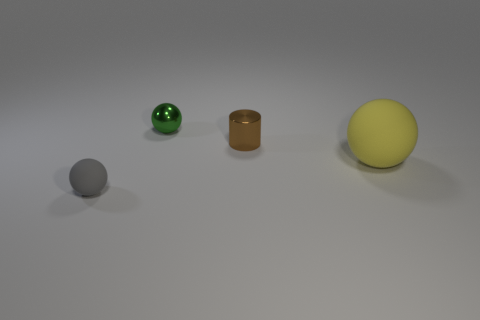Are there any other things that are the same size as the yellow sphere?
Make the answer very short. No. There is a large yellow thing that is the same shape as the tiny matte object; what is it made of?
Make the answer very short. Rubber. Do the brown thing and the green ball have the same material?
Your answer should be compact. Yes. There is a tiny ball that is behind the rubber sphere on the left side of the big sphere; what color is it?
Give a very brief answer. Green. The green thing that is the same material as the small brown thing is what size?
Provide a succinct answer. Small. How many large yellow things have the same shape as the small rubber thing?
Provide a succinct answer. 1. How many things are brown things that are on the left side of the yellow object or small metal things to the left of the small brown metallic cylinder?
Make the answer very short. 2. What number of yellow objects are on the left side of the ball on the right side of the shiny sphere?
Provide a succinct answer. 0. Does the tiny thing in front of the tiny brown cylinder have the same shape as the rubber object behind the gray rubber sphere?
Your answer should be very brief. Yes. Is there another thing made of the same material as the tiny green thing?
Your answer should be compact. Yes. 